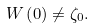Convert formula to latex. <formula><loc_0><loc_0><loc_500><loc_500>W \left ( 0 \right ) \neq \zeta _ { 0 } .</formula> 